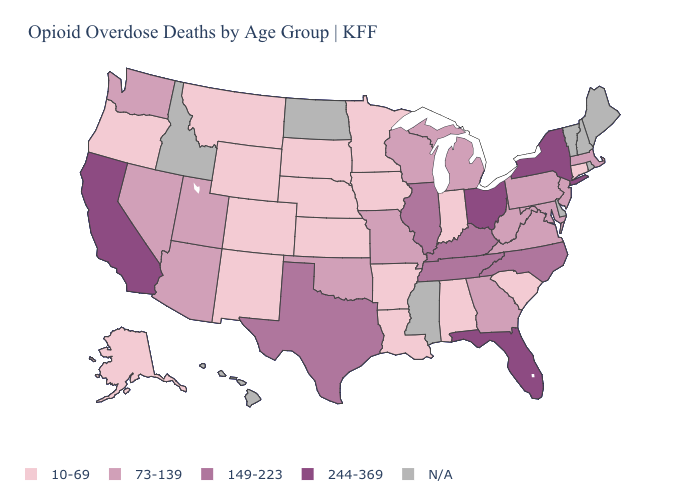Does Connecticut have the lowest value in the Northeast?
Be succinct. Yes. What is the value of Alabama?
Give a very brief answer. 10-69. What is the value of Colorado?
Short answer required. 10-69. Does the map have missing data?
Short answer required. Yes. What is the value of Illinois?
Short answer required. 149-223. How many symbols are there in the legend?
Concise answer only. 5. Which states have the lowest value in the USA?
Concise answer only. Alabama, Alaska, Arkansas, Colorado, Connecticut, Indiana, Iowa, Kansas, Louisiana, Minnesota, Montana, Nebraska, New Mexico, Oregon, South Carolina, South Dakota, Wyoming. Which states have the highest value in the USA?
Keep it brief. California, Florida, New York, Ohio. Does South Dakota have the lowest value in the USA?
Write a very short answer. Yes. Among the states that border California , does Nevada have the highest value?
Answer briefly. Yes. What is the highest value in states that border Nevada?
Give a very brief answer. 244-369. Which states have the lowest value in the USA?
Keep it brief. Alabama, Alaska, Arkansas, Colorado, Connecticut, Indiana, Iowa, Kansas, Louisiana, Minnesota, Montana, Nebraska, New Mexico, Oregon, South Carolina, South Dakota, Wyoming. Among the states that border Washington , which have the lowest value?
Be succinct. Oregon. 